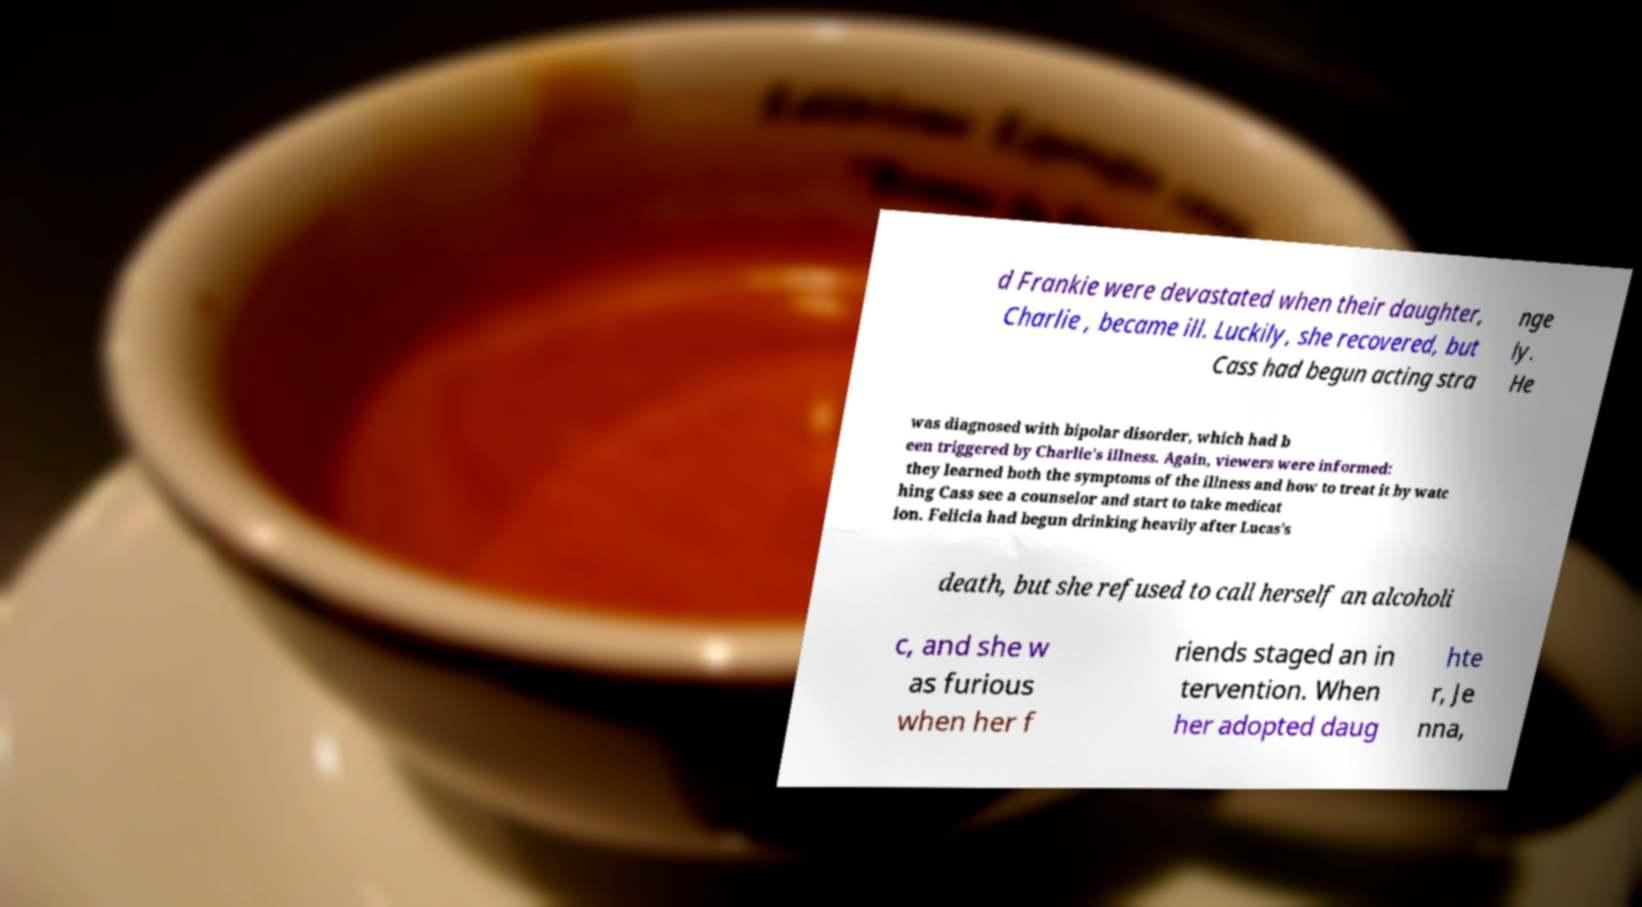Can you accurately transcribe the text from the provided image for me? d Frankie were devastated when their daughter, Charlie , became ill. Luckily, she recovered, but Cass had begun acting stra nge ly. He was diagnosed with bipolar disorder, which had b een triggered by Charlie's illness. Again, viewers were informed: they learned both the symptoms of the illness and how to treat it by watc hing Cass see a counselor and start to take medicat ion. Felicia had begun drinking heavily after Lucas's death, but she refused to call herself an alcoholi c, and she w as furious when her f riends staged an in tervention. When her adopted daug hte r, Je nna, 